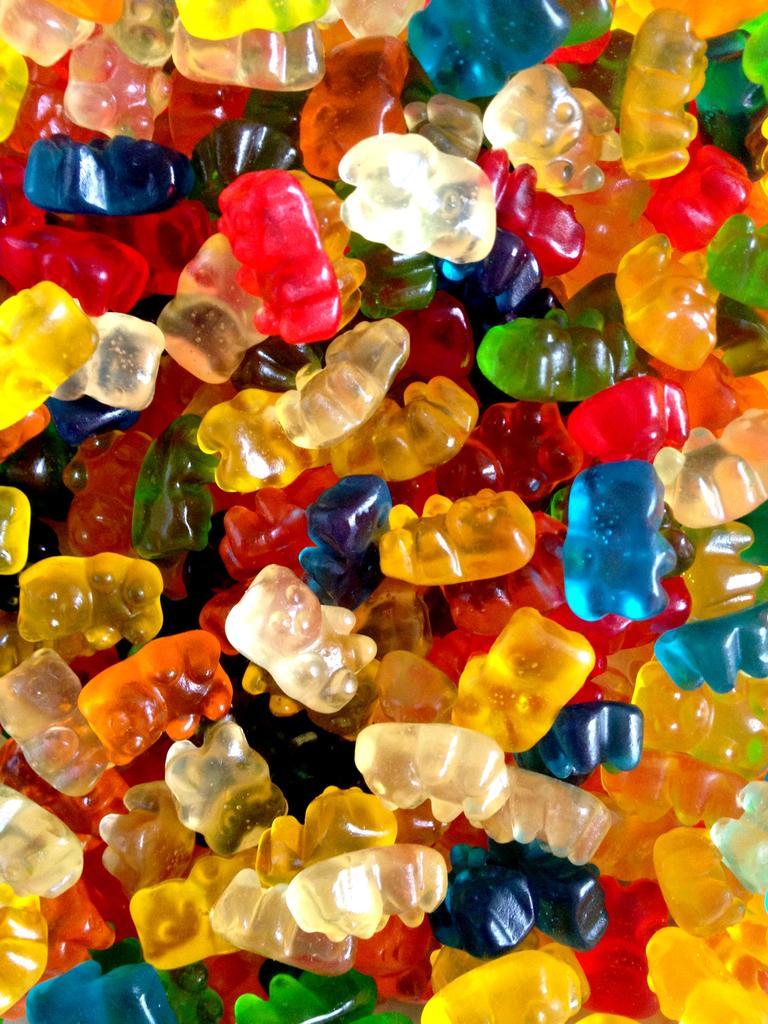In one or two sentences, can you explain what this image depicts? In this image there are jellies.. 